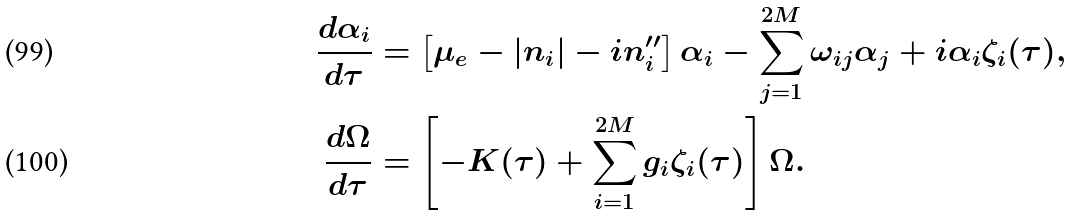<formula> <loc_0><loc_0><loc_500><loc_500>\frac { d \alpha _ { i } } { d \tau } & = \left [ \mu _ { e } - | n _ { i } | - i n _ { i } ^ { \prime \prime } \right ] \alpha _ { i } - \sum _ { j = 1 } ^ { 2 M } \omega _ { i j } \alpha _ { j } + i \alpha _ { i } \zeta _ { i } ( \tau ) , \\ \frac { d \Omega } { d \tau } & = \left [ - K ( \tau ) + \sum _ { i = 1 } ^ { 2 M } g _ { i } \zeta _ { i } ( \tau ) \right ] \Omega .</formula> 